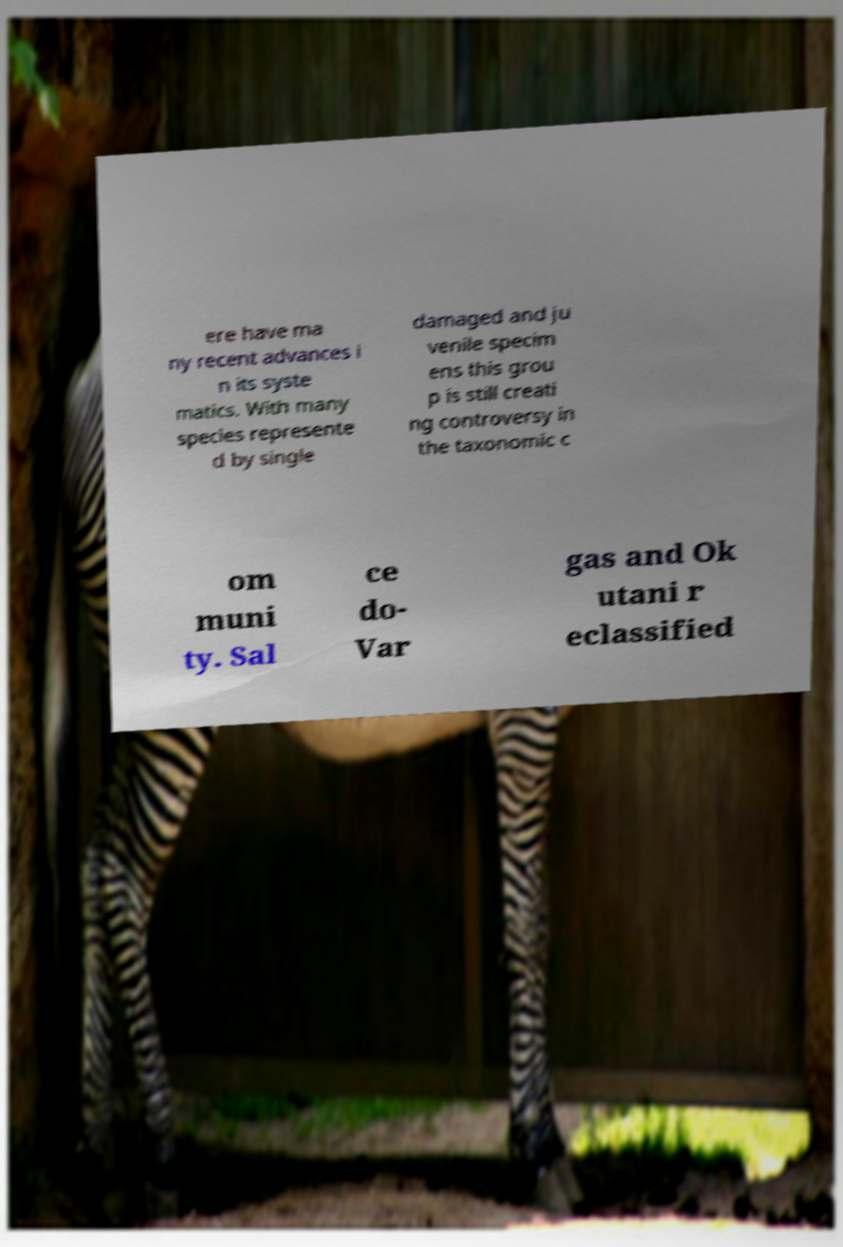Can you accurately transcribe the text from the provided image for me? ere have ma ny recent advances i n its syste matics. With many species represente d by single damaged and ju venile specim ens this grou p is still creati ng controversy in the taxonomic c om muni ty. Sal ce do- Var gas and Ok utani r eclassified 